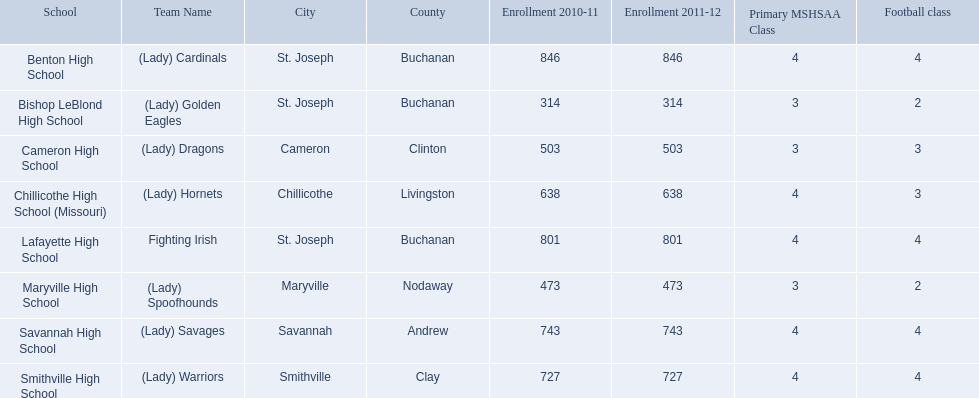What team uses green and grey as colors? Fighting Irish. What is this team called? Lafayette High School. 